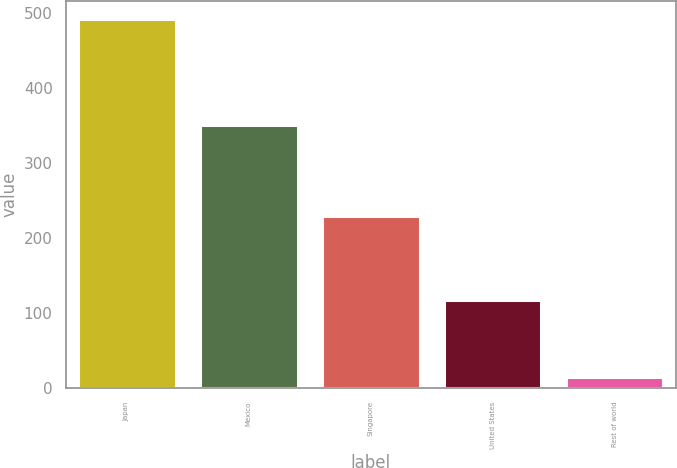<chart> <loc_0><loc_0><loc_500><loc_500><bar_chart><fcel>Japan<fcel>Mexico<fcel>Singapore<fcel>United States<fcel>Rest of world<nl><fcel>491.9<fcel>351.5<fcel>229.9<fcel>117.6<fcel>14.7<nl></chart> 